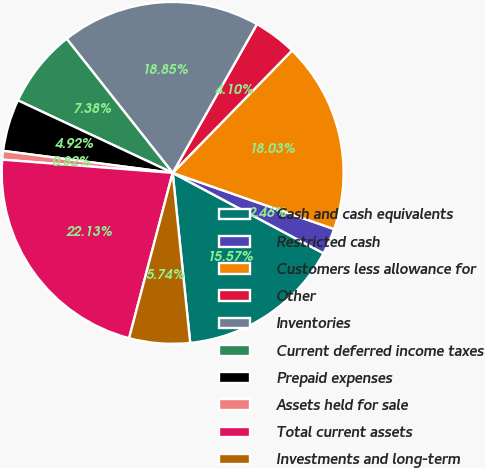<chart> <loc_0><loc_0><loc_500><loc_500><pie_chart><fcel>Cash and cash equivalents<fcel>Restricted cash<fcel>Customers less allowance for<fcel>Other<fcel>Inventories<fcel>Current deferred income taxes<fcel>Prepaid expenses<fcel>Assets held for sale<fcel>Total current assets<fcel>Investments and long-term<nl><fcel>15.57%<fcel>2.46%<fcel>18.03%<fcel>4.1%<fcel>18.85%<fcel>7.38%<fcel>4.92%<fcel>0.82%<fcel>22.13%<fcel>5.74%<nl></chart> 